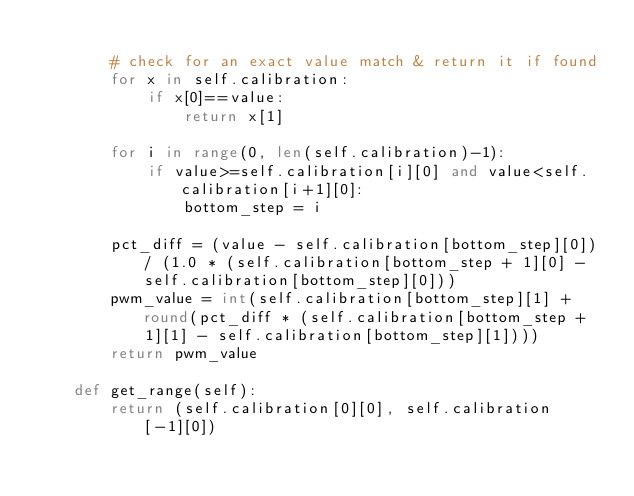<code> <loc_0><loc_0><loc_500><loc_500><_Python_>
        # check for an exact value match & return it if found
        for x in self.calibration:
            if x[0]==value:
                return x[1]

        for i in range(0, len(self.calibration)-1):
            if value>=self.calibration[i][0] and value<self.calibration[i+1][0]:
                bottom_step = i

        pct_diff = (value - self.calibration[bottom_step][0]) / (1.0 * (self.calibration[bottom_step + 1][0] - self.calibration[bottom_step][0]))
        pwm_value = int(self.calibration[bottom_step][1] + round(pct_diff * (self.calibration[bottom_step + 1][1] - self.calibration[bottom_step][1])))
        return pwm_value

    def get_range(self):
        return (self.calibration[0][0], self.calibration[-1][0])
</code> 